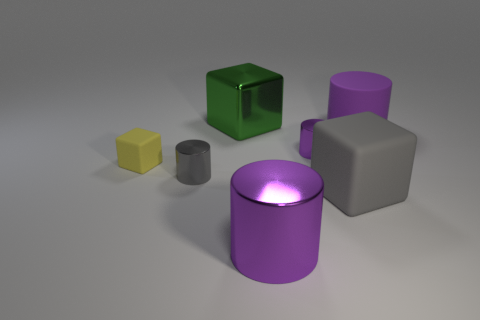There is a metallic object behind the tiny purple thing that is behind the purple shiny thing in front of the small gray shiny thing; what size is it?
Keep it short and to the point. Large. What size is the cube that is behind the big gray block and to the right of the small yellow block?
Offer a terse response. Large. Does the small thing behind the small yellow matte object have the same color as the big metal thing behind the purple matte thing?
Offer a terse response. No. There is a yellow rubber block; how many rubber blocks are left of it?
Provide a short and direct response. 0. There is a large purple object behind the rubber cube that is behind the gray shiny object; is there a thing that is to the right of it?
Keep it short and to the point. No. What number of objects have the same size as the yellow matte cube?
Your answer should be very brief. 2. What material is the large object on the right side of the gray thing to the right of the green shiny thing made of?
Your answer should be very brief. Rubber. The large thing that is behind the matte thing behind the shiny cylinder that is behind the small matte block is what shape?
Make the answer very short. Cube. Is the shape of the purple metallic object behind the big metal cylinder the same as the large green thing that is behind the small gray cylinder?
Offer a very short reply. No. How many other objects are the same material as the yellow thing?
Your response must be concise. 2. 